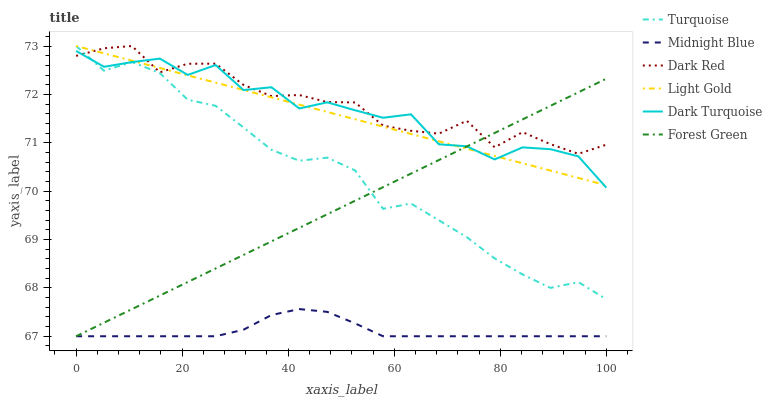Does Midnight Blue have the minimum area under the curve?
Answer yes or no. Yes. Does Dark Red have the maximum area under the curve?
Answer yes or no. Yes. Does Dark Red have the minimum area under the curve?
Answer yes or no. No. Does Midnight Blue have the maximum area under the curve?
Answer yes or no. No. Is Forest Green the smoothest?
Answer yes or no. Yes. Is Dark Turquoise the roughest?
Answer yes or no. Yes. Is Midnight Blue the smoothest?
Answer yes or no. No. Is Midnight Blue the roughest?
Answer yes or no. No. Does Dark Red have the lowest value?
Answer yes or no. No. Does Midnight Blue have the highest value?
Answer yes or no. No. Is Midnight Blue less than Turquoise?
Answer yes or no. Yes. Is Dark Red greater than Midnight Blue?
Answer yes or no. Yes. Does Midnight Blue intersect Turquoise?
Answer yes or no. No. 